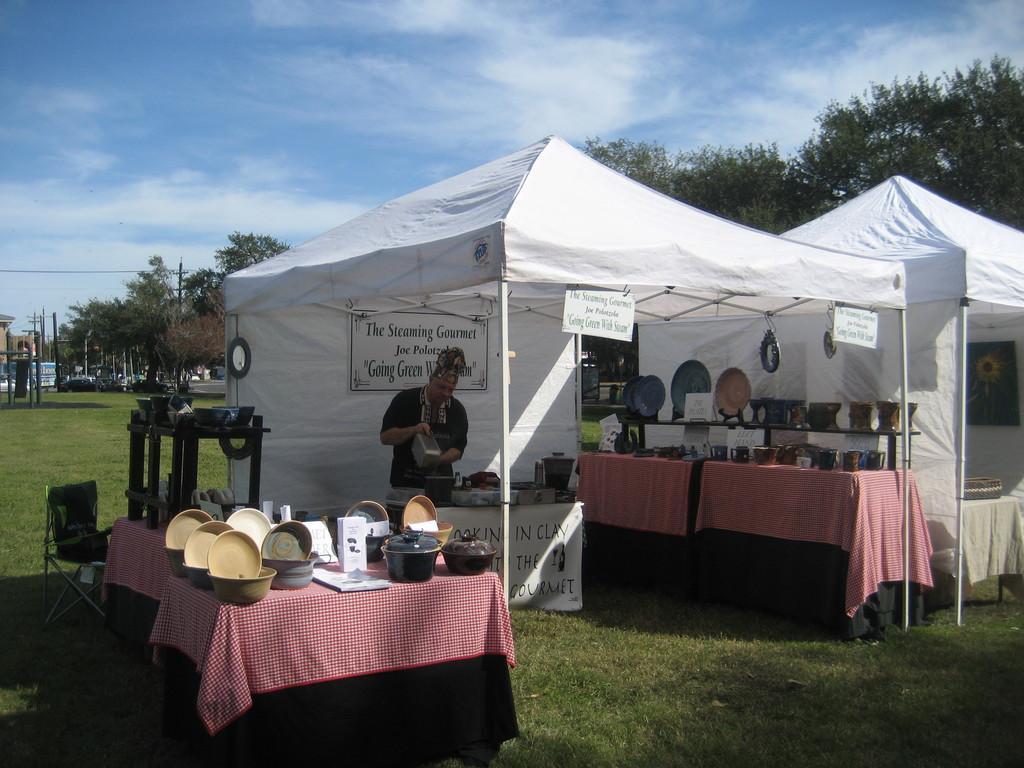Can you describe this image briefly? There are tents with poles. On the tents there are banners. Also there are tables with tablecloths. On the tables there are bowls and many other items. On the left side there is a chair. On the tables there are stands. On the stands there are bowls and some items. There is a person standing inside the tent. In the background there are trees and sky with clouds. 